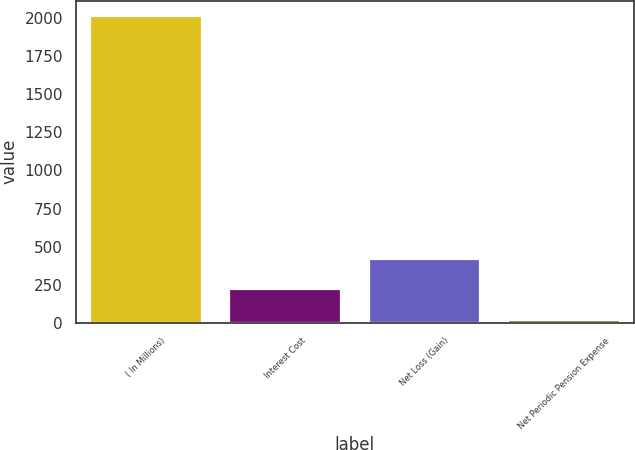Convert chart to OTSL. <chart><loc_0><loc_0><loc_500><loc_500><bar_chart><fcel>( In Millions)<fcel>Interest Cost<fcel>Net Loss (Gain)<fcel>Net Periodic Pension Expense<nl><fcel>2013<fcel>220.38<fcel>419.56<fcel>21.2<nl></chart> 